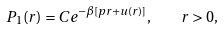Convert formula to latex. <formula><loc_0><loc_0><loc_500><loc_500>P _ { 1 } ( r ) = C e ^ { - \beta [ p r + u ( r ) ] } , \quad r > 0 ,</formula> 